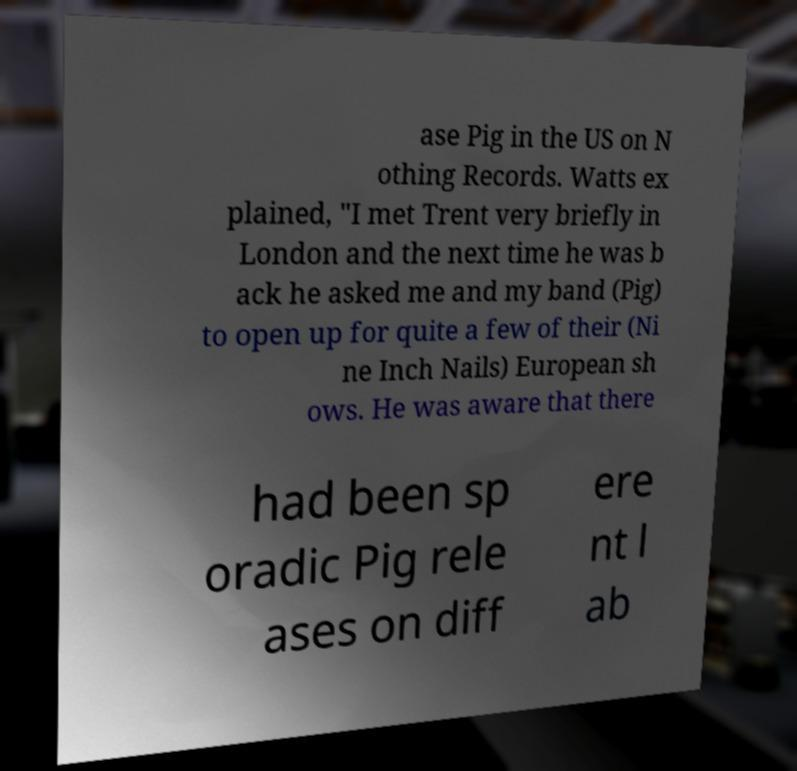Could you extract and type out the text from this image? ase Pig in the US on N othing Records. Watts ex plained, "I met Trent very briefly in London and the next time he was b ack he asked me and my band (Pig) to open up for quite a few of their (Ni ne Inch Nails) European sh ows. He was aware that there had been sp oradic Pig rele ases on diff ere nt l ab 